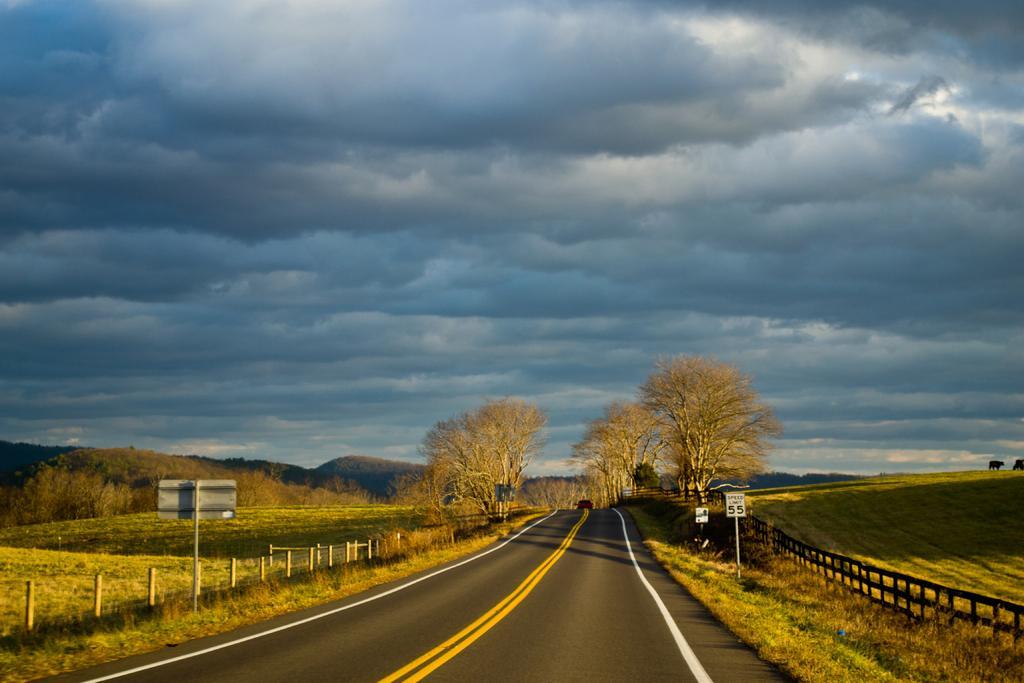Could you give a brief overview of what you see in this image? This image is clicked on the road. At the bottom, there is a road. In the front, we can see a car. On the left and right, there are trees and green grass on the ground along with fencing. At the top, there are clouds in the sky. 